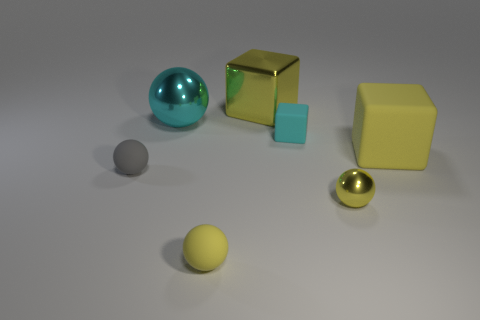Subtract 1 balls. How many balls are left? 3 Add 2 small gray spheres. How many objects exist? 9 Subtract all spheres. How many objects are left? 3 Add 1 big cyan metallic spheres. How many big cyan metallic spheres are left? 2 Add 5 small green blocks. How many small green blocks exist? 5 Subtract 0 purple blocks. How many objects are left? 7 Subtract all yellow matte balls. Subtract all cyan spheres. How many objects are left? 5 